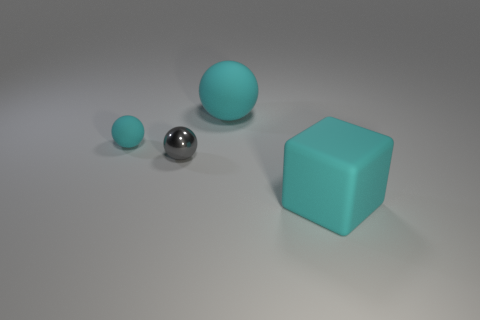Subtract 1 spheres. How many spheres are left? 2 Add 2 cyan matte balls. How many objects exist? 6 Subtract all balls. How many objects are left? 1 Add 2 cyan matte cubes. How many cyan matte cubes are left? 3 Add 4 big blocks. How many big blocks exist? 5 Subtract 0 red cylinders. How many objects are left? 4 Subtract all large objects. Subtract all red shiny cubes. How many objects are left? 2 